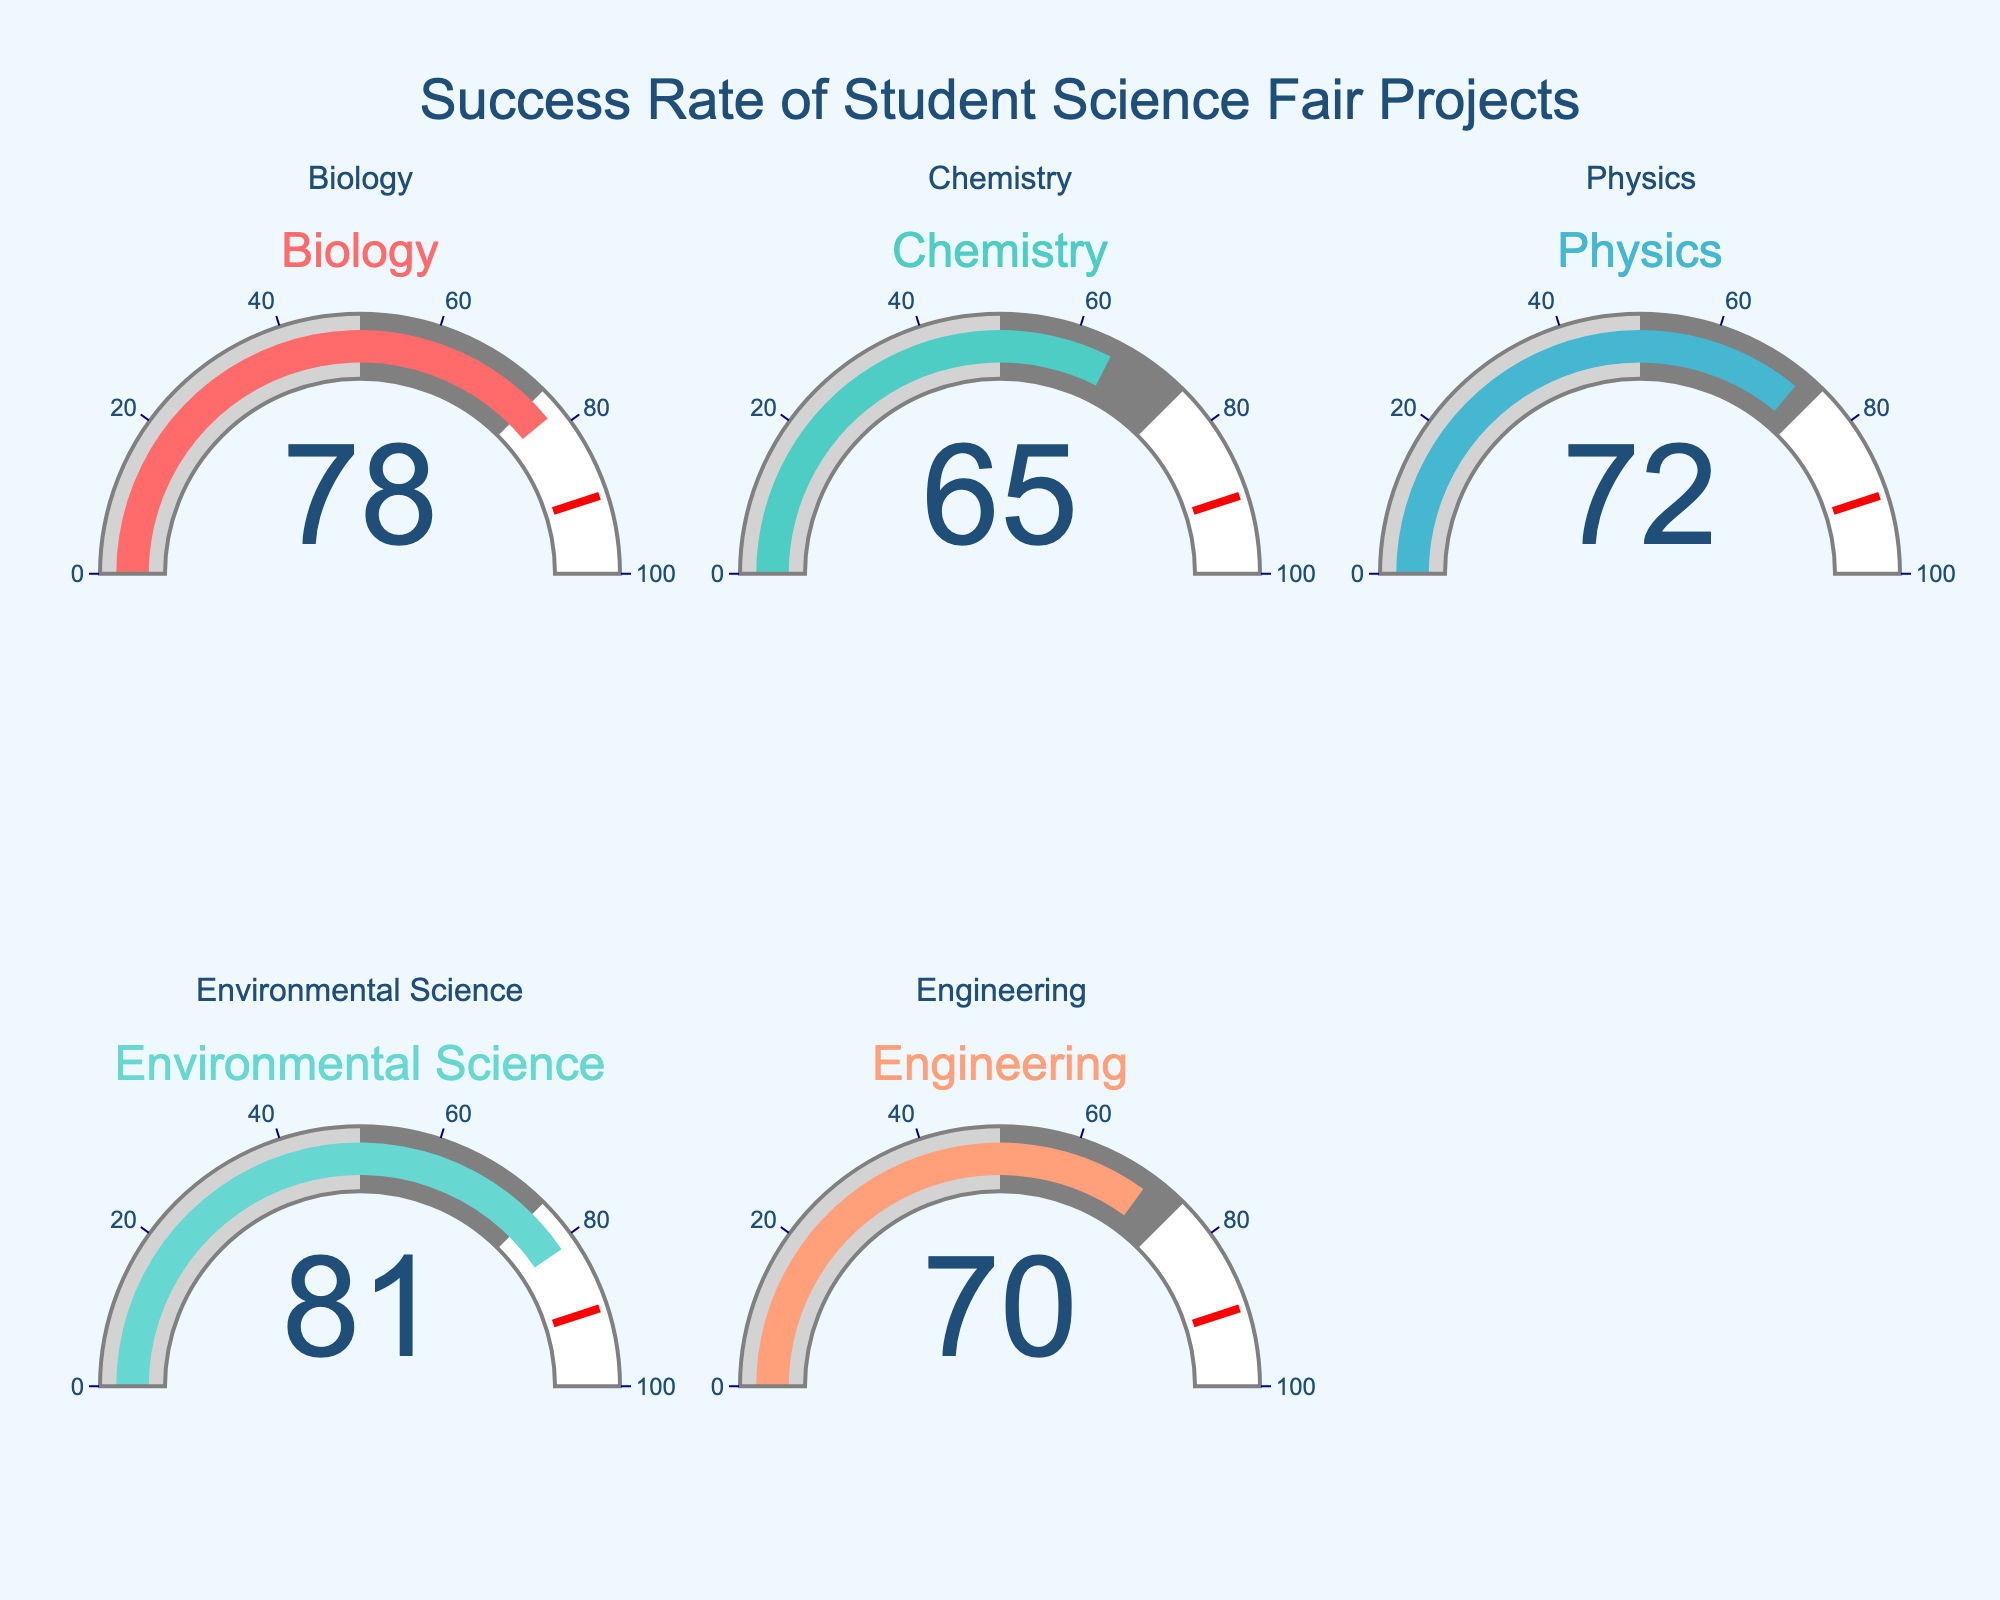What is the success rate for Biology projects? The gauge for Biology shows a success rate of 78.
Answer: 78 Which category has the highest success rate? By comparing the numbers on each gauge, Environmental Science has the highest value of 81.
Answer: Environmental Science What is the average success rate of all categories? Sum all success rates (78 + 65 + 72 + 81 + 70) and divide by the number of categories (5): (78 + 65 + 72 + 81 + 70) / 5 = 366 / 5 = 73.2.
Answer: 73.2 Between Chemistry and Engineering, which has a higher success rate? By comparing their gauges, Chemistry has 65 and Engineering has 70. Therefore, Engineering has a higher success rate.
Answer: Engineering How many categories have a success rate above 75? Biology (78), Environmental Science (81) are above 75. So there are two categories.
Answer: 2 What is the difference in success rate between Physics and Chemistry? The success rate for Physics is 72 and for Chemistry is 65. The difference is 72 - 65 = 7.
Answer: 7 What percentage range is the Engineering category in based on the gauge background? The gauge has a background range; in the gauge for Engineering (success rate 70), it is in the range of 50 to 75.
Answer: 50 to 75 Which category has the smallest success rate? By comparing the numbers on each gauge, Chemistry has the smallest success rate of 65.
Answer: Chemistry What is the median success rate among all categories? Arrange the success rates in ascending order (65, 70, 72, 78, 81). The median is the middle value, which is 72.
Answer: 72 